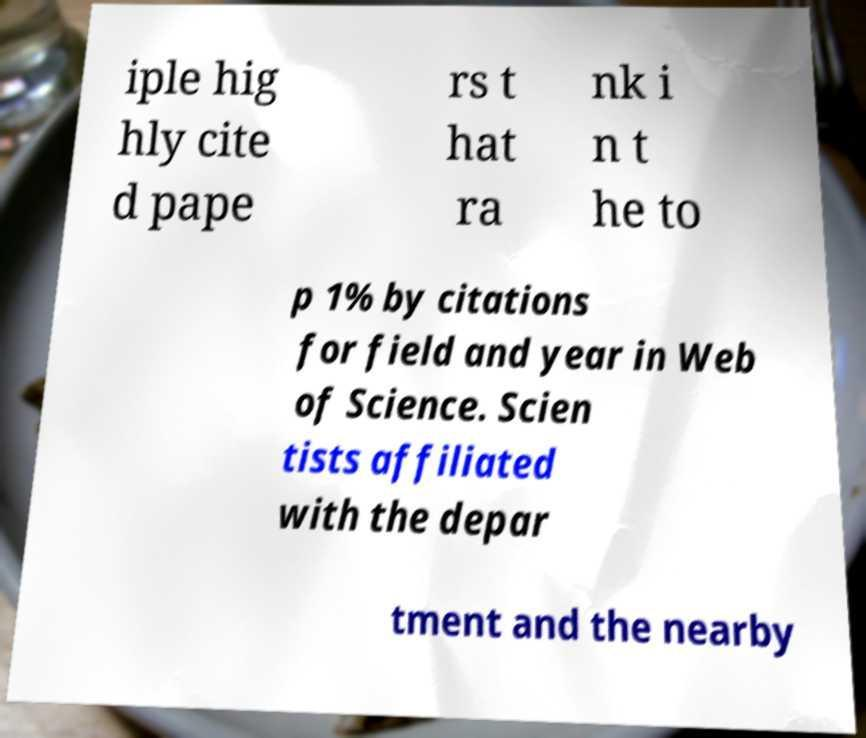What messages or text are displayed in this image? I need them in a readable, typed format. iple hig hly cite d pape rs t hat ra nk i n t he to p 1% by citations for field and year in Web of Science. Scien tists affiliated with the depar tment and the nearby 